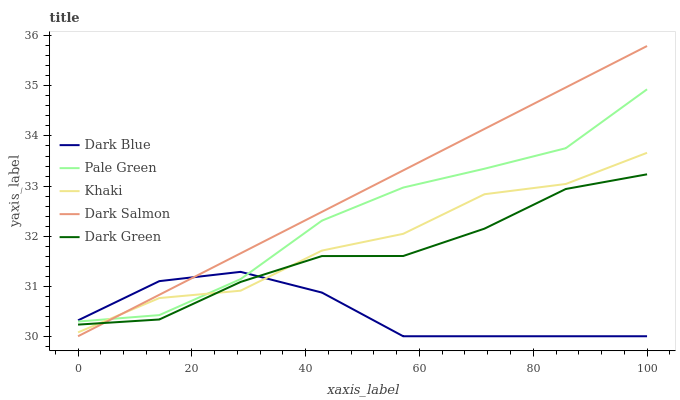Does Dark Blue have the minimum area under the curve?
Answer yes or no. Yes. Does Dark Salmon have the maximum area under the curve?
Answer yes or no. Yes. Does Pale Green have the minimum area under the curve?
Answer yes or no. No. Does Pale Green have the maximum area under the curve?
Answer yes or no. No. Is Dark Salmon the smoothest?
Answer yes or no. Yes. Is Khaki the roughest?
Answer yes or no. Yes. Is Dark Blue the smoothest?
Answer yes or no. No. Is Dark Blue the roughest?
Answer yes or no. No. Does Dark Blue have the lowest value?
Answer yes or no. Yes. Does Pale Green have the lowest value?
Answer yes or no. No. Does Dark Salmon have the highest value?
Answer yes or no. Yes. Does Pale Green have the highest value?
Answer yes or no. No. Is Dark Green less than Pale Green?
Answer yes or no. Yes. Is Pale Green greater than Dark Green?
Answer yes or no. Yes. Does Pale Green intersect Dark Salmon?
Answer yes or no. Yes. Is Pale Green less than Dark Salmon?
Answer yes or no. No. Is Pale Green greater than Dark Salmon?
Answer yes or no. No. Does Dark Green intersect Pale Green?
Answer yes or no. No. 